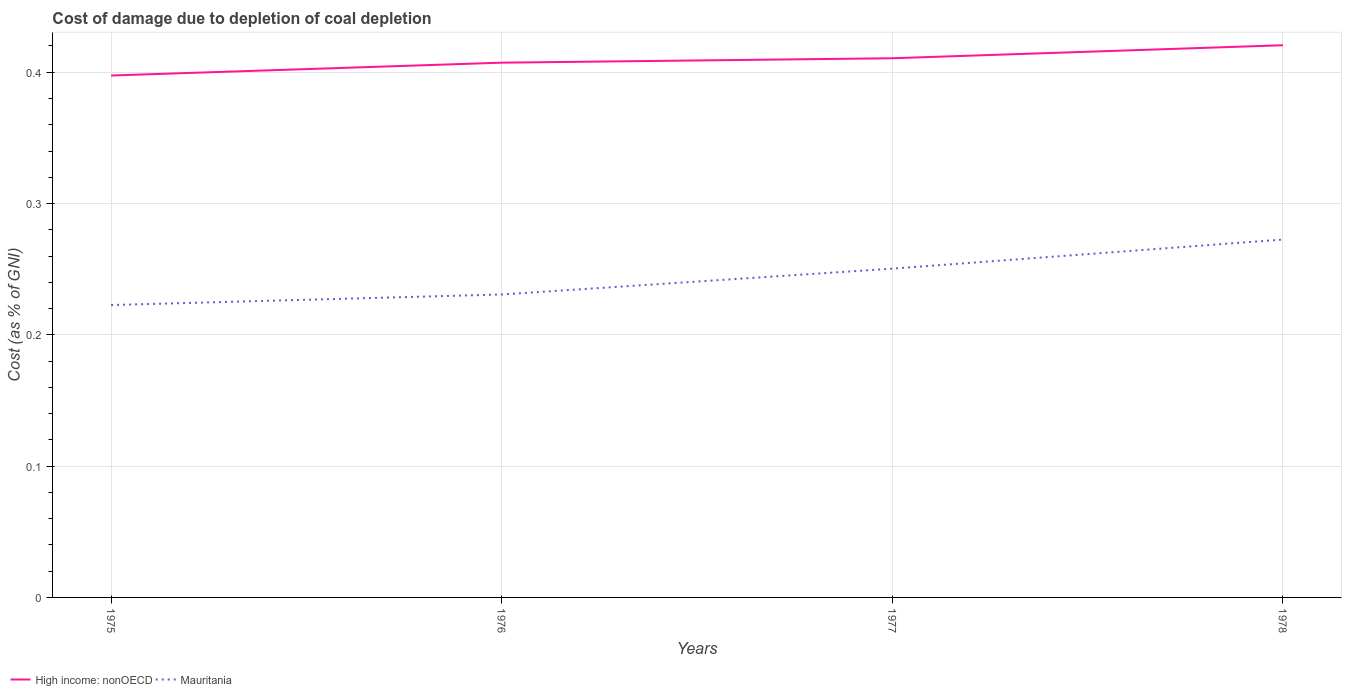How many different coloured lines are there?
Give a very brief answer. 2. Does the line corresponding to Mauritania intersect with the line corresponding to High income: nonOECD?
Ensure brevity in your answer.  No. Across all years, what is the maximum cost of damage caused due to coal depletion in High income: nonOECD?
Offer a very short reply. 0.4. In which year was the cost of damage caused due to coal depletion in Mauritania maximum?
Provide a succinct answer. 1975. What is the total cost of damage caused due to coal depletion in Mauritania in the graph?
Ensure brevity in your answer.  -0.01. What is the difference between the highest and the second highest cost of damage caused due to coal depletion in Mauritania?
Provide a short and direct response. 0.05. How many lines are there?
Offer a terse response. 2. What is the difference between two consecutive major ticks on the Y-axis?
Offer a terse response. 0.1. Are the values on the major ticks of Y-axis written in scientific E-notation?
Keep it short and to the point. No. Does the graph contain any zero values?
Your answer should be very brief. No. Where does the legend appear in the graph?
Keep it short and to the point. Bottom left. How are the legend labels stacked?
Provide a short and direct response. Horizontal. What is the title of the graph?
Make the answer very short. Cost of damage due to depletion of coal depletion. Does "Togo" appear as one of the legend labels in the graph?
Keep it short and to the point. No. What is the label or title of the Y-axis?
Ensure brevity in your answer.  Cost (as % of GNI). What is the Cost (as % of GNI) in High income: nonOECD in 1975?
Make the answer very short. 0.4. What is the Cost (as % of GNI) of Mauritania in 1975?
Your answer should be very brief. 0.22. What is the Cost (as % of GNI) of High income: nonOECD in 1976?
Provide a succinct answer. 0.41. What is the Cost (as % of GNI) in Mauritania in 1976?
Provide a succinct answer. 0.23. What is the Cost (as % of GNI) of High income: nonOECD in 1977?
Keep it short and to the point. 0.41. What is the Cost (as % of GNI) of Mauritania in 1977?
Provide a short and direct response. 0.25. What is the Cost (as % of GNI) of High income: nonOECD in 1978?
Your answer should be very brief. 0.42. What is the Cost (as % of GNI) in Mauritania in 1978?
Keep it short and to the point. 0.27. Across all years, what is the maximum Cost (as % of GNI) of High income: nonOECD?
Provide a short and direct response. 0.42. Across all years, what is the maximum Cost (as % of GNI) of Mauritania?
Give a very brief answer. 0.27. Across all years, what is the minimum Cost (as % of GNI) of High income: nonOECD?
Provide a short and direct response. 0.4. Across all years, what is the minimum Cost (as % of GNI) in Mauritania?
Keep it short and to the point. 0.22. What is the total Cost (as % of GNI) in High income: nonOECD in the graph?
Your answer should be compact. 1.64. What is the total Cost (as % of GNI) of Mauritania in the graph?
Provide a succinct answer. 0.98. What is the difference between the Cost (as % of GNI) of High income: nonOECD in 1975 and that in 1976?
Keep it short and to the point. -0.01. What is the difference between the Cost (as % of GNI) in Mauritania in 1975 and that in 1976?
Offer a terse response. -0.01. What is the difference between the Cost (as % of GNI) of High income: nonOECD in 1975 and that in 1977?
Offer a terse response. -0.01. What is the difference between the Cost (as % of GNI) of Mauritania in 1975 and that in 1977?
Provide a succinct answer. -0.03. What is the difference between the Cost (as % of GNI) of High income: nonOECD in 1975 and that in 1978?
Your response must be concise. -0.02. What is the difference between the Cost (as % of GNI) of Mauritania in 1975 and that in 1978?
Keep it short and to the point. -0.05. What is the difference between the Cost (as % of GNI) of High income: nonOECD in 1976 and that in 1977?
Offer a very short reply. -0. What is the difference between the Cost (as % of GNI) of Mauritania in 1976 and that in 1977?
Ensure brevity in your answer.  -0.02. What is the difference between the Cost (as % of GNI) of High income: nonOECD in 1976 and that in 1978?
Offer a terse response. -0.01. What is the difference between the Cost (as % of GNI) in Mauritania in 1976 and that in 1978?
Offer a terse response. -0.04. What is the difference between the Cost (as % of GNI) in High income: nonOECD in 1977 and that in 1978?
Provide a short and direct response. -0.01. What is the difference between the Cost (as % of GNI) in Mauritania in 1977 and that in 1978?
Your response must be concise. -0.02. What is the difference between the Cost (as % of GNI) in High income: nonOECD in 1975 and the Cost (as % of GNI) in Mauritania in 1976?
Your answer should be very brief. 0.17. What is the difference between the Cost (as % of GNI) in High income: nonOECD in 1975 and the Cost (as % of GNI) in Mauritania in 1977?
Make the answer very short. 0.15. What is the difference between the Cost (as % of GNI) in High income: nonOECD in 1975 and the Cost (as % of GNI) in Mauritania in 1978?
Offer a terse response. 0.12. What is the difference between the Cost (as % of GNI) of High income: nonOECD in 1976 and the Cost (as % of GNI) of Mauritania in 1977?
Give a very brief answer. 0.16. What is the difference between the Cost (as % of GNI) of High income: nonOECD in 1976 and the Cost (as % of GNI) of Mauritania in 1978?
Offer a very short reply. 0.13. What is the difference between the Cost (as % of GNI) of High income: nonOECD in 1977 and the Cost (as % of GNI) of Mauritania in 1978?
Your answer should be compact. 0.14. What is the average Cost (as % of GNI) of High income: nonOECD per year?
Make the answer very short. 0.41. What is the average Cost (as % of GNI) in Mauritania per year?
Your response must be concise. 0.24. In the year 1975, what is the difference between the Cost (as % of GNI) of High income: nonOECD and Cost (as % of GNI) of Mauritania?
Provide a succinct answer. 0.17. In the year 1976, what is the difference between the Cost (as % of GNI) in High income: nonOECD and Cost (as % of GNI) in Mauritania?
Provide a succinct answer. 0.18. In the year 1977, what is the difference between the Cost (as % of GNI) in High income: nonOECD and Cost (as % of GNI) in Mauritania?
Keep it short and to the point. 0.16. In the year 1978, what is the difference between the Cost (as % of GNI) of High income: nonOECD and Cost (as % of GNI) of Mauritania?
Your response must be concise. 0.15. What is the ratio of the Cost (as % of GNI) in High income: nonOECD in 1975 to that in 1976?
Provide a succinct answer. 0.98. What is the ratio of the Cost (as % of GNI) in Mauritania in 1975 to that in 1976?
Provide a short and direct response. 0.97. What is the ratio of the Cost (as % of GNI) of High income: nonOECD in 1975 to that in 1977?
Make the answer very short. 0.97. What is the ratio of the Cost (as % of GNI) in Mauritania in 1975 to that in 1977?
Your response must be concise. 0.89. What is the ratio of the Cost (as % of GNI) in High income: nonOECD in 1975 to that in 1978?
Make the answer very short. 0.95. What is the ratio of the Cost (as % of GNI) of Mauritania in 1975 to that in 1978?
Keep it short and to the point. 0.82. What is the ratio of the Cost (as % of GNI) in High income: nonOECD in 1976 to that in 1977?
Ensure brevity in your answer.  0.99. What is the ratio of the Cost (as % of GNI) of Mauritania in 1976 to that in 1977?
Provide a succinct answer. 0.92. What is the ratio of the Cost (as % of GNI) in High income: nonOECD in 1976 to that in 1978?
Ensure brevity in your answer.  0.97. What is the ratio of the Cost (as % of GNI) in Mauritania in 1976 to that in 1978?
Keep it short and to the point. 0.85. What is the ratio of the Cost (as % of GNI) in High income: nonOECD in 1977 to that in 1978?
Your response must be concise. 0.98. What is the ratio of the Cost (as % of GNI) in Mauritania in 1977 to that in 1978?
Your response must be concise. 0.92. What is the difference between the highest and the second highest Cost (as % of GNI) in High income: nonOECD?
Give a very brief answer. 0.01. What is the difference between the highest and the second highest Cost (as % of GNI) of Mauritania?
Your answer should be very brief. 0.02. What is the difference between the highest and the lowest Cost (as % of GNI) of High income: nonOECD?
Offer a terse response. 0.02. What is the difference between the highest and the lowest Cost (as % of GNI) of Mauritania?
Offer a very short reply. 0.05. 